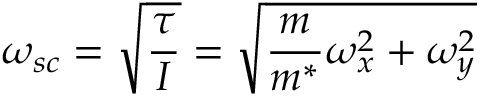<formula> <loc_0><loc_0><loc_500><loc_500>\omega _ { s c } = \sqrt { \frac { \tau } { I } } = \sqrt { \frac { m } { m ^ { * } } \omega _ { x } ^ { 2 } + \omega _ { y } ^ { 2 } }</formula> 